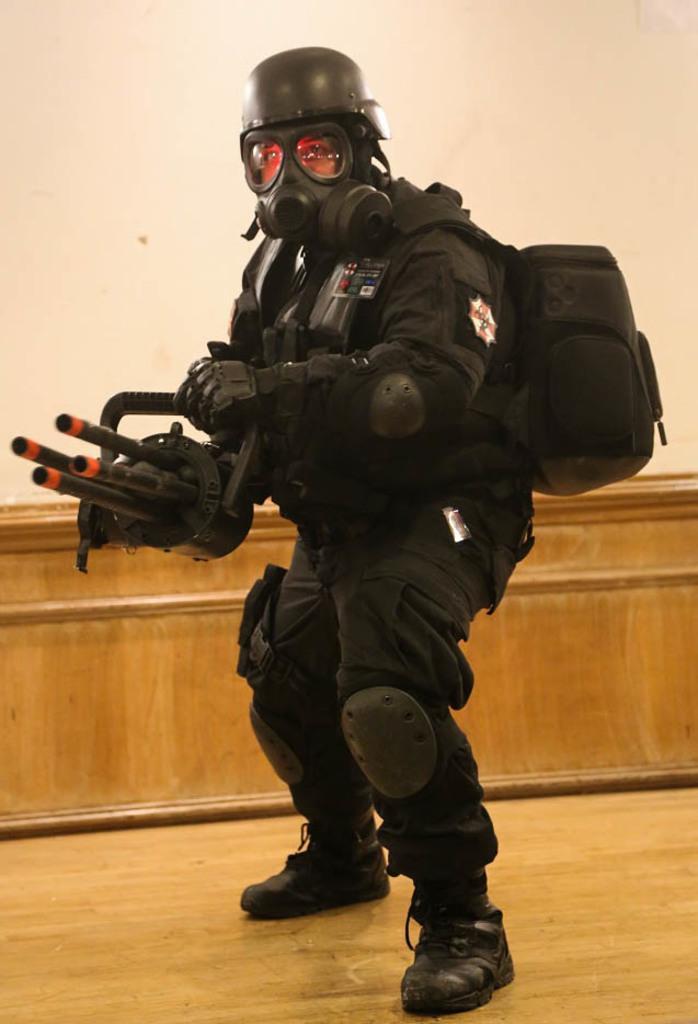How would you summarize this image in a sentence or two? In this image we can see a man wearing black color dress, a backpack and holding an object in his hands and cream color wall in the background. 